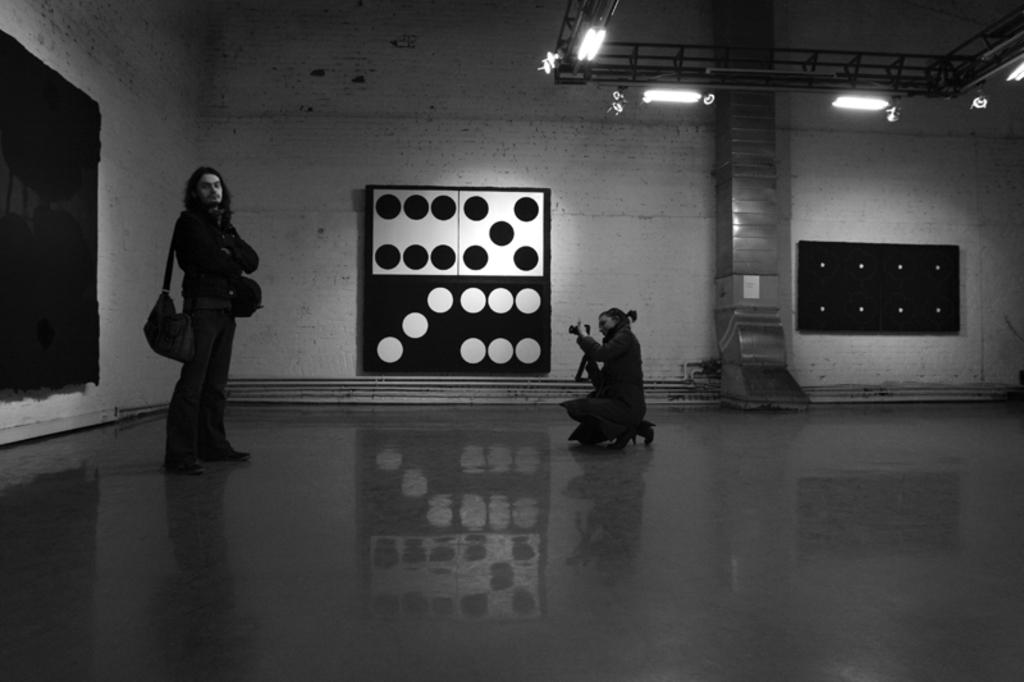What is the main action being performed by the person in the image? There is a person giving a pose in the image. Who is capturing the pose in the image? There is another person holding a camera in the image. What can be seen on the wall in the image? There is a dice poster on the wall in the image. What is visible at the top of the image? There are lights visible at the top of the image. What type of destruction can be seen happening to the chess pieces in the image? There is no destruction or chess pieces present in the image. Who is the judge overseeing the competition in the image? There is no judge or competition present in the image. 